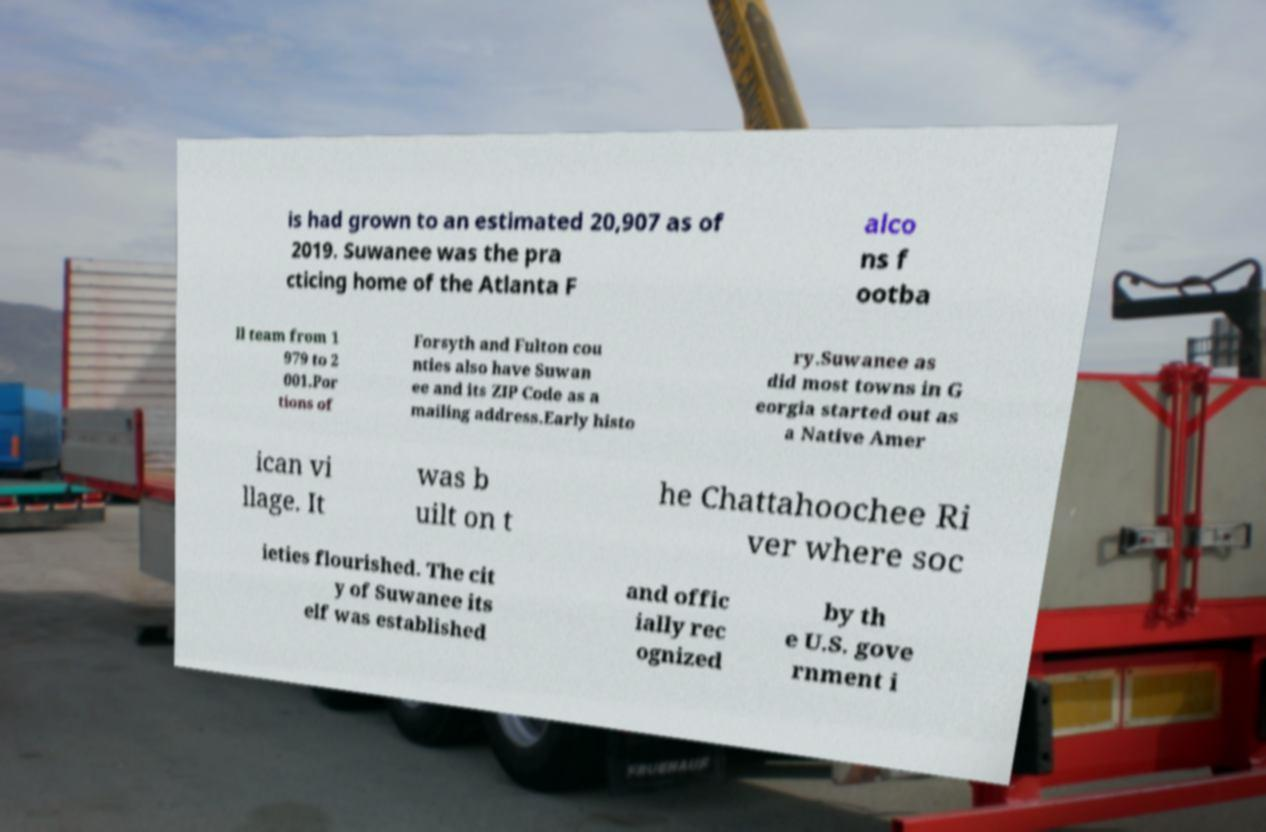Can you read and provide the text displayed in the image?This photo seems to have some interesting text. Can you extract and type it out for me? is had grown to an estimated 20,907 as of 2019. Suwanee was the pra cticing home of the Atlanta F alco ns f ootba ll team from 1 979 to 2 001.Por tions of Forsyth and Fulton cou nties also have Suwan ee and its ZIP Code as a mailing address.Early histo ry.Suwanee as did most towns in G eorgia started out as a Native Amer ican vi llage. It was b uilt on t he Chattahoochee Ri ver where soc ieties flourished. The cit y of Suwanee its elf was established and offic ially rec ognized by th e U.S. gove rnment i 